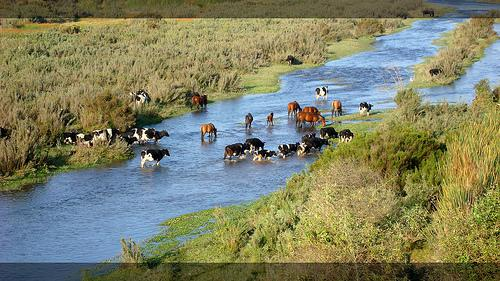Question: what are the cows doing?
Choices:
A. Chewing cud.
B. Giving birth.
C. Running.
D. Crossing river.
Answer with the letter. Answer: D Question: what are the animals?
Choices:
A. Armadillos.
B. Squid.
C. Cows.
D. Cicadas.
Answer with the letter. Answer: C Question: how many people are in the picture?
Choices:
A. 1.
B. 2.
C. None.
D. 4.
Answer with the letter. Answer: C Question: who is in the picture?
Choices:
A. Pirates.
B. No one.
C. Refugees.
D. Death row inmates.
Answer with the letter. Answer: B Question: where are the cows going?
Choices:
A. Into a cave.
B. Towards the barn.
C. Right.
D. Away from the coyotes.
Answer with the letter. Answer: C Question: what is in the river?
Choices:
A. Fish.
B. Cows.
C. Water.
D. Boats.
Answer with the letter. Answer: B Question: what colors are the cows?
Choices:
A. Brown.
B. Beige.
C. Black, white, and brown.
D. Green.
Answer with the letter. Answer: C 